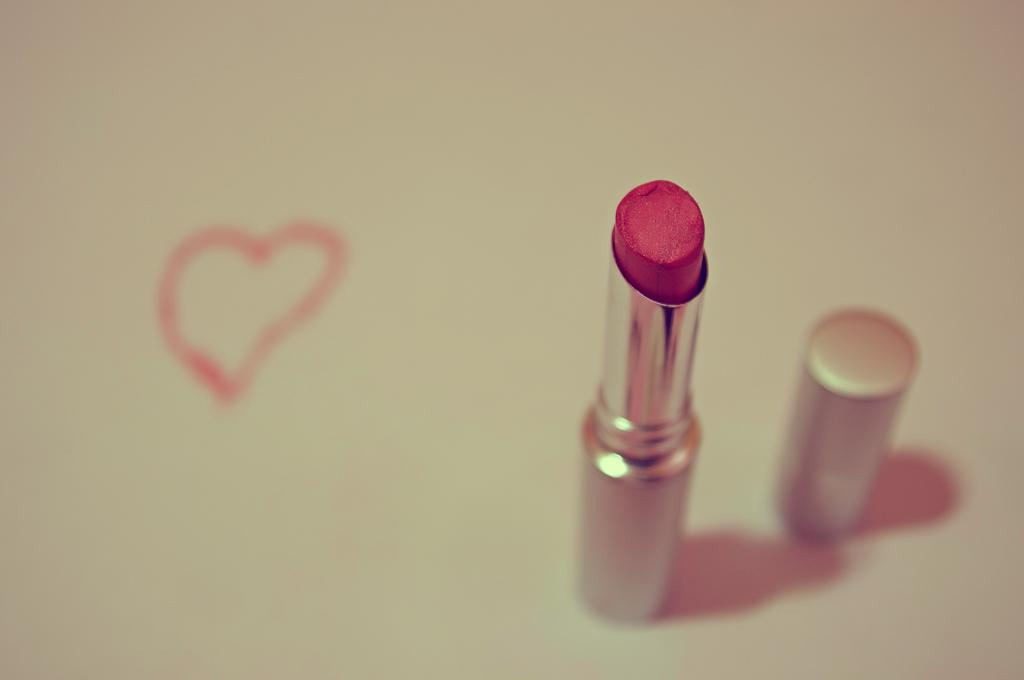What object is present on the floor in the image? There is a lipstick on the floor in the image. What is the position of the lipstick's cap in relation to the lipstick? The lipstick's cap is beside it. What type of bread can be seen in the image? There is no bread present in the image; it features a lipstick on the floor with its cap beside it. 